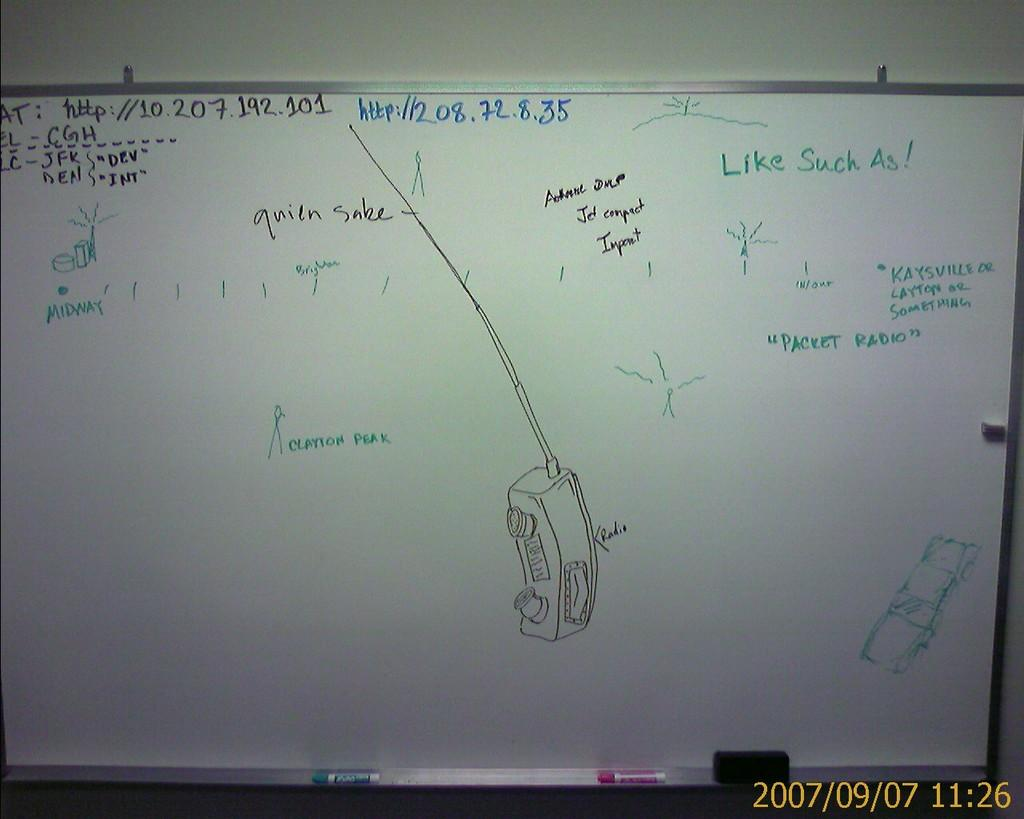<image>
Create a compact narrative representing the image presented. A drawing of a walkie-talkie has the word "radio" on it on the whiteboard. 